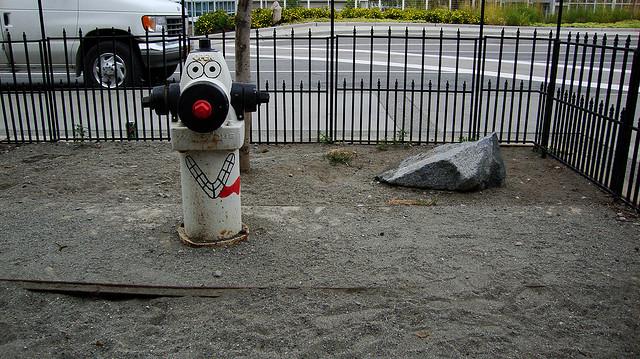Is there writing on the fire hydrant?
Quick response, please. No. What encloses the yard?
Give a very brief answer. Fence. Would this fence be easy to climb over?
Concise answer only. No. 